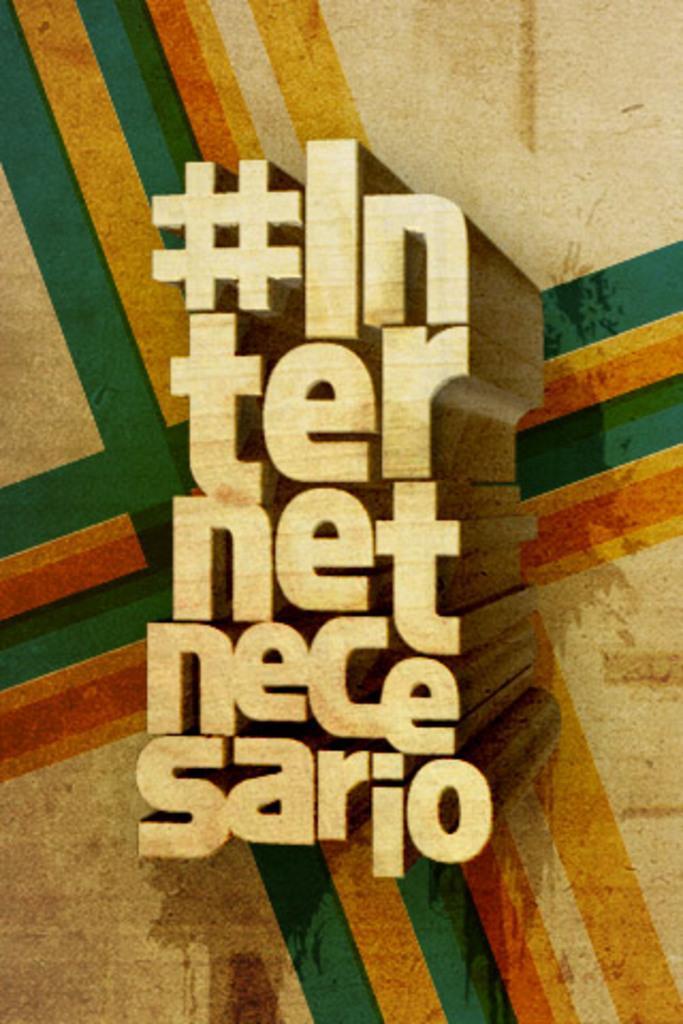Please provide a concise description of this image. In this picture we can see a poster, there is some text in the middle. 